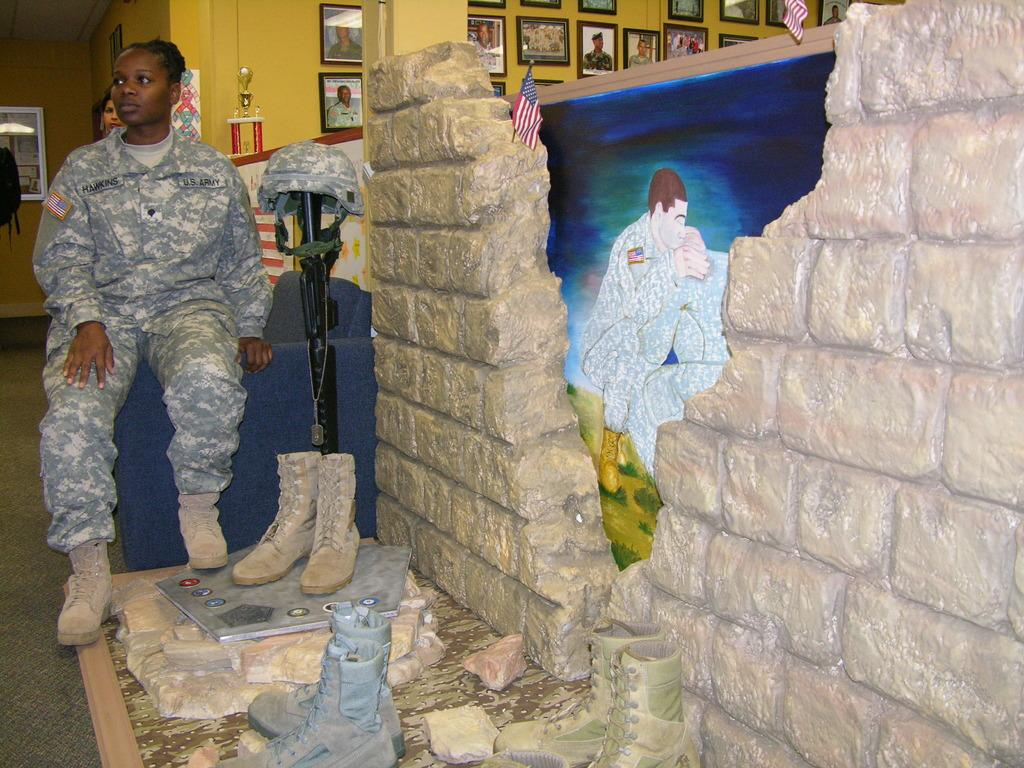What is the woman in the image doing? The woman is sitting in the image. What type of footwear can be seen in the image? There are boots in the image. What decorative items are present in the image? There are flags and photo frames on the wall in the background of the image. What type of artwork is visible in the background of the image? There is a painting in the background of the image. How many pies are being held by the woman's wing in the image? There is no wing or pies present in the image. 